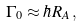<formula> <loc_0><loc_0><loc_500><loc_500>\Gamma _ { 0 } \approx \hbar { R } _ { A } \, ,</formula> 